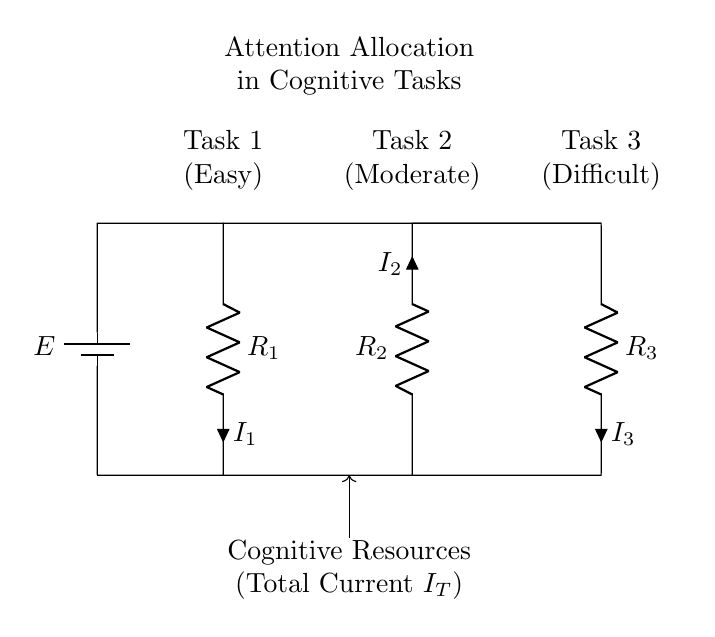What is the total current entering the circuit? The total current entering the circuit is labeled as I_T, which represents the sum of currents flowing through each resistor in the parallel configuration.
Answer: I_T What are the three tasks indicated in the circuit? The tasks indicated are Task 1 (Easy), Task 2 (Moderate), and Task 3 (Difficult), corresponding to each resistor in the circuit.
Answer: Easy, Moderate, Difficult Which resistor has the highest current allocated to it? In a current divider, the resistor with the lowest resistance has the highest current. Looking at the circuit, if R_1 is the lowest resistance, then it has the highest current allocation, which is I_1.
Answer: I_1 How many resistors are present in this circuit? The circuit diagram shows three resistors (R_1, R_2, and R_3) connected in parallel, indicating that there are three resistors present.
Answer: Three What does the symbol E represent in the circuit? The symbol E represents the voltage source or battery providing the necessary potential difference to drive the current through the circuit.
Answer: Voltage source If R_1 is 10 ohms, R_2 is 20 ohms, and R_3 is 30 ohms, what is the current through R_2 if I_T is 6A? In a current divider, the current through a resistor is inversely proportional to its resistance. Since R_2 has a resistance of 20 ohms, we apply the formula I_2 = I_T * (R_total / R_2). First, calculate R_total = 1/(1/R_1 + 1/R_2 + 1/R_3), then find I_2. For R_1, R_2, and R_3 respectively, the currents become I_1 = 2A, I_2 = 1.5A, and I_3 = 1A. Thus, I_2 is approximately 2A. Therefore, I_2 is correct when calculations yield 2A through simulation or calculations based on values.
Answer: 2A 